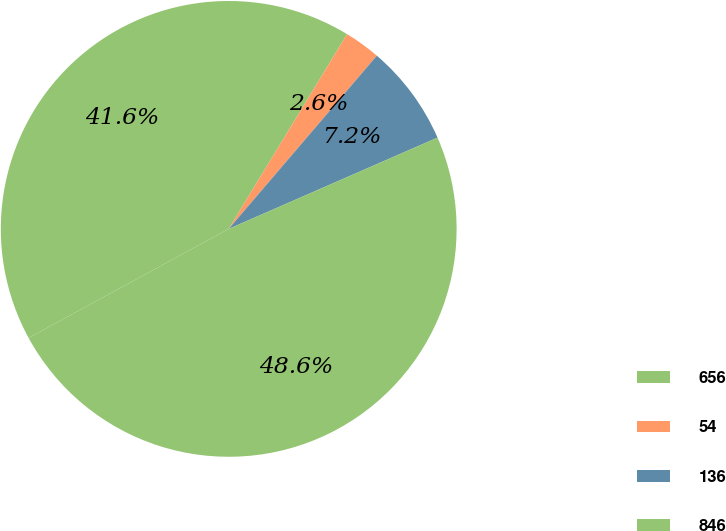<chart> <loc_0><loc_0><loc_500><loc_500><pie_chart><fcel>656<fcel>54<fcel>136<fcel>846<nl><fcel>41.63%<fcel>2.57%<fcel>7.18%<fcel>48.62%<nl></chart> 